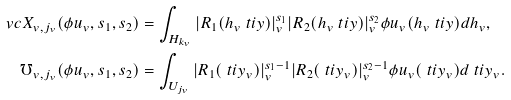Convert formula to latex. <formula><loc_0><loc_0><loc_500><loc_500>\ v c X _ { v , j _ { v } } ( \phi u _ { v } , s _ { 1 } , s _ { 2 } ) & = \int _ { H _ { k _ { v } } } | R _ { 1 } ( h _ { v } \ t i y ) | _ { v } ^ { s _ { 1 } } | R _ { 2 } ( h _ { v } \ t i y ) | _ { v } ^ { s _ { 2 } } \phi u _ { v } ( h _ { v } \ t i y ) d h _ { v } , \\ \mho _ { v , j _ { v } } ( \phi u _ { v } , s _ { 1 } , s _ { 2 } ) & = \int _ { U _ { j _ { v } } } | R _ { 1 } ( \ t i y _ { v } ) | _ { v } ^ { s _ { 1 } - 1 } | R _ { 2 } ( \ t i y _ { v } ) | _ { v } ^ { s _ { 2 } - 1 } \phi u _ { v } ( \ t i y _ { v } ) d \ t i y _ { v } .</formula> 